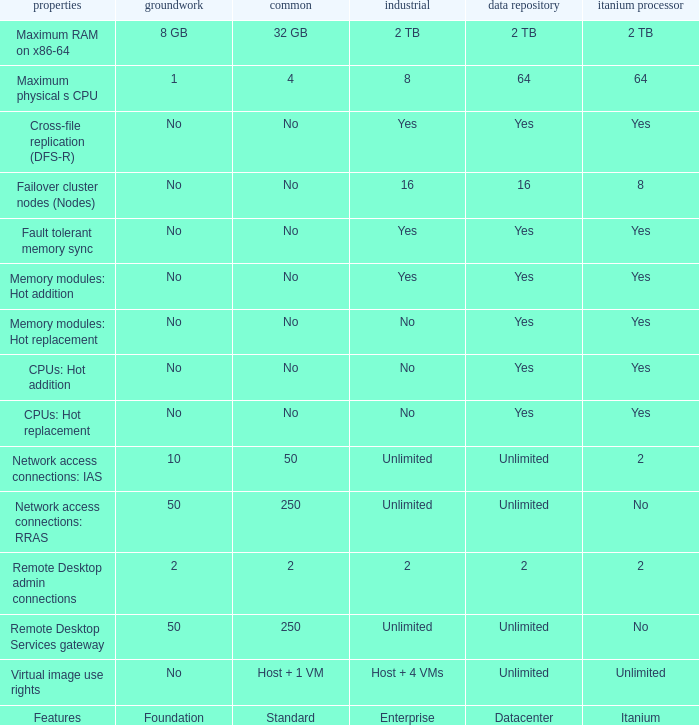What Datacenter is listed against the network access connections: rras Feature? Unlimited. 